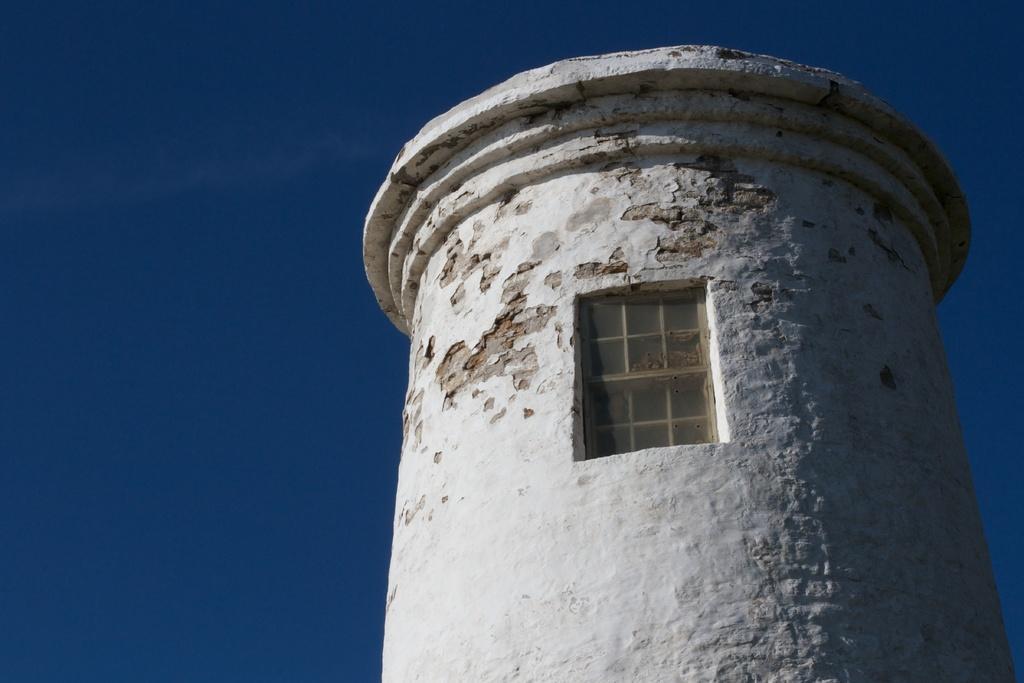Please provide a concise description of this image. In this image we can see a tower and a window. In the background there is sky. 